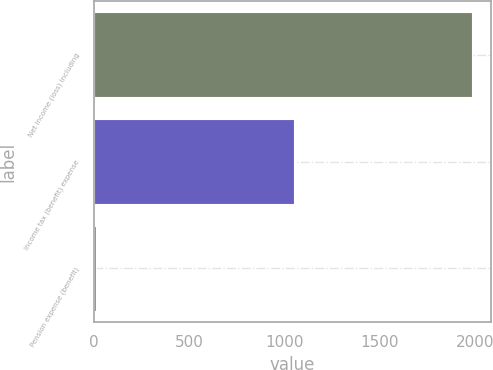Convert chart to OTSL. <chart><loc_0><loc_0><loc_500><loc_500><bar_chart><fcel>Net income (loss) including<fcel>Income tax (benefit) expense<fcel>Pension expense (benefit)<nl><fcel>1981.8<fcel>1050.7<fcel>10<nl></chart> 